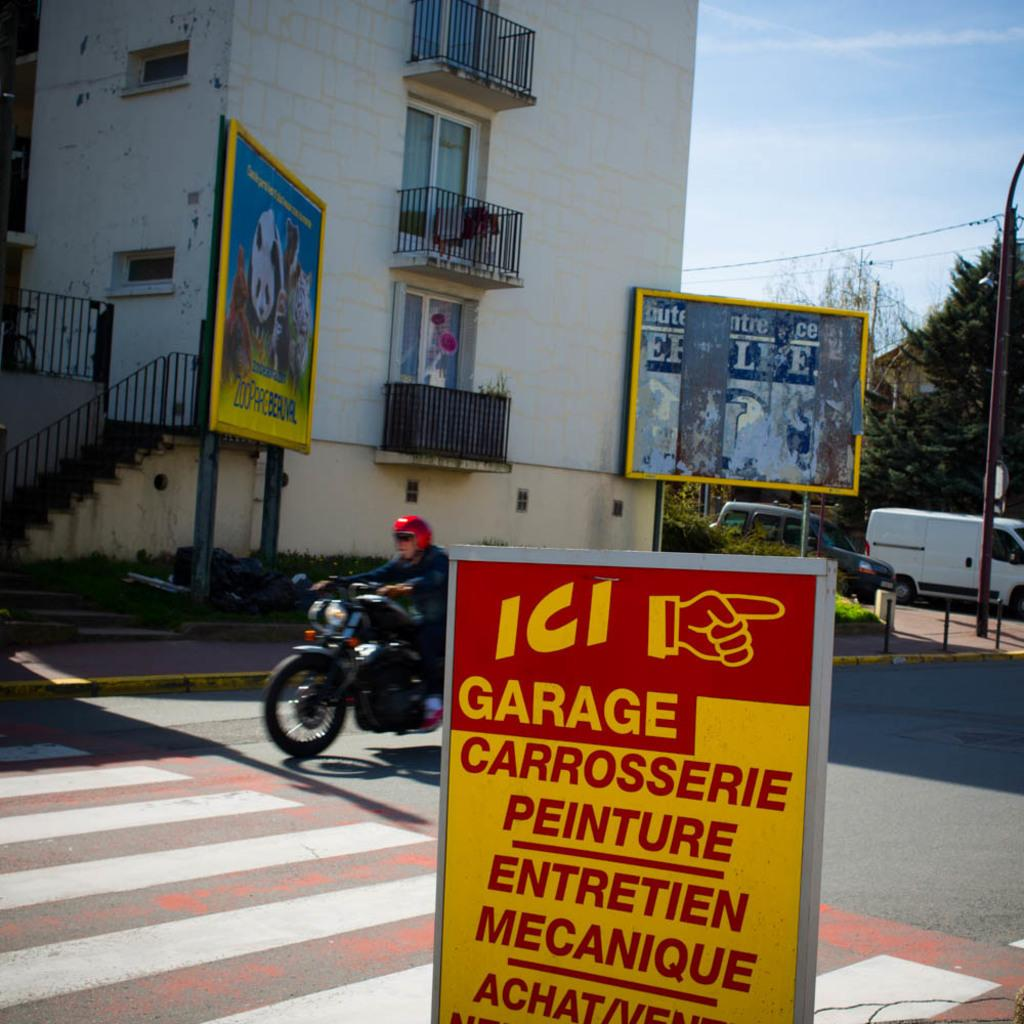What is the man in the image doing? The man is riding a bike in the image. What is located at the bottom of the image? There is a board at the bottom of the image. What can be seen in the background of the image? There are hoardings, a pole, cars, trees, a building, and the sky visible in the background of the image. What type of throat-soothing remedy is being advertised on the channel in the image? There is no channel or throat-soothing remedy present in the image. 